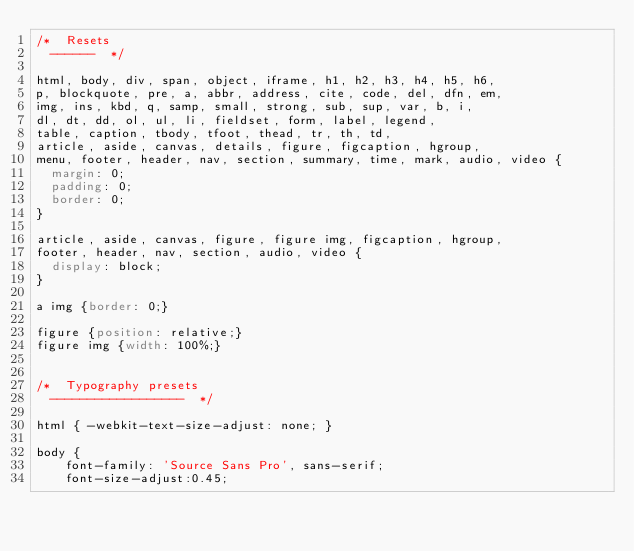<code> <loc_0><loc_0><loc_500><loc_500><_CSS_>/*	Resets
	------	*/

html, body, div, span, object, iframe, h1, h2, h3, h4, h5, h6, 
p, blockquote, pre, a, abbr, address, cite, code, del, dfn, em, 
img, ins, kbd, q, samp, small, strong, sub, sup, var, b, i, 
dl, dt, dd, ol, ul, li, fieldset, form, label, legend, 
table, caption, tbody, tfoot, thead, tr, th, td,
article, aside, canvas, details, figure, figcaption, hgroup, 
menu, footer, header, nav, section, summary, time, mark, audio, video {
	margin: 0;
	padding: 0;
	border: 0;
}

article, aside, canvas, figure, figure img, figcaption, hgroup,
footer, header, nav, section, audio, video {
	display: block;
}

a img {border: 0;}

figure {position: relative;}
figure img {width: 100%;}


/*	Typography presets
	------------------	*/

html { -webkit-text-size-adjust: none; }

body {
    font-family: 'Source Sans Pro', sans-serif;
    font-size-adjust:0.45;</code> 